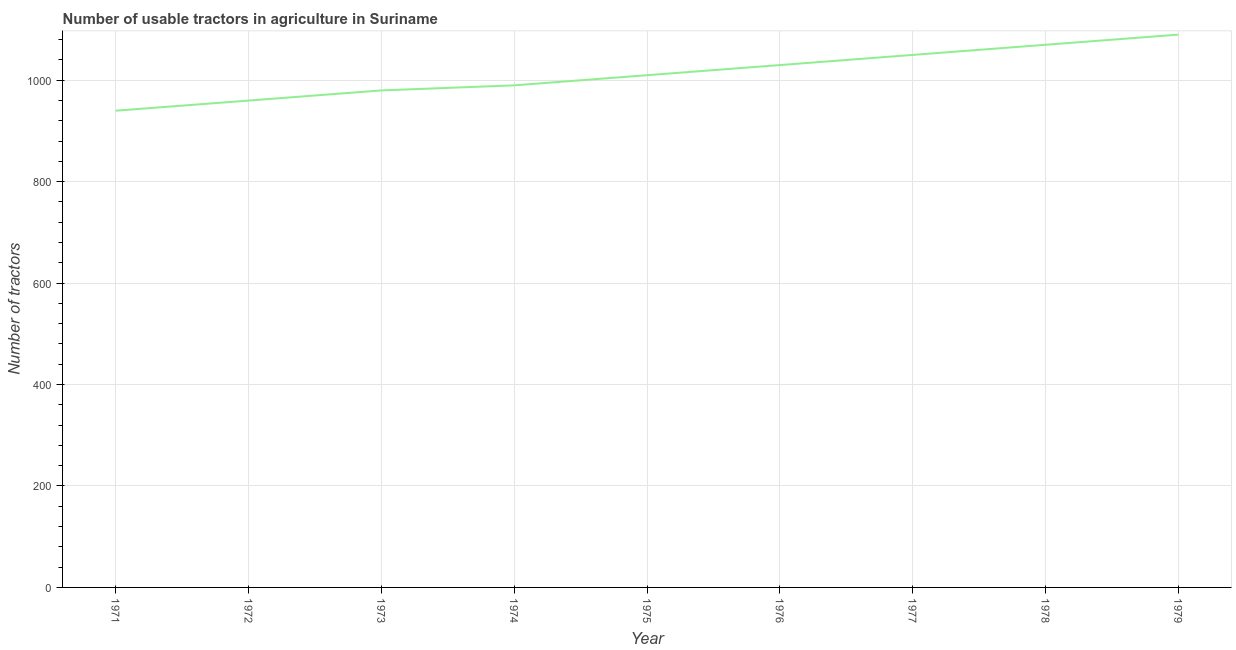What is the number of tractors in 1972?
Your response must be concise. 960. Across all years, what is the maximum number of tractors?
Give a very brief answer. 1090. Across all years, what is the minimum number of tractors?
Offer a terse response. 940. In which year was the number of tractors maximum?
Your answer should be very brief. 1979. What is the sum of the number of tractors?
Make the answer very short. 9120. What is the difference between the number of tractors in 1973 and 1977?
Give a very brief answer. -70. What is the average number of tractors per year?
Provide a short and direct response. 1013.33. What is the median number of tractors?
Provide a succinct answer. 1010. In how many years, is the number of tractors greater than 800 ?
Ensure brevity in your answer.  9. What is the ratio of the number of tractors in 1971 to that in 1973?
Give a very brief answer. 0.96. What is the difference between the highest and the second highest number of tractors?
Your answer should be compact. 20. What is the difference between the highest and the lowest number of tractors?
Your response must be concise. 150. What is the difference between two consecutive major ticks on the Y-axis?
Offer a terse response. 200. Are the values on the major ticks of Y-axis written in scientific E-notation?
Give a very brief answer. No. What is the title of the graph?
Your answer should be very brief. Number of usable tractors in agriculture in Suriname. What is the label or title of the Y-axis?
Offer a very short reply. Number of tractors. What is the Number of tractors of 1971?
Make the answer very short. 940. What is the Number of tractors of 1972?
Give a very brief answer. 960. What is the Number of tractors of 1973?
Offer a terse response. 980. What is the Number of tractors in 1974?
Make the answer very short. 990. What is the Number of tractors in 1975?
Make the answer very short. 1010. What is the Number of tractors in 1976?
Provide a succinct answer. 1030. What is the Number of tractors of 1977?
Ensure brevity in your answer.  1050. What is the Number of tractors of 1978?
Your answer should be very brief. 1070. What is the Number of tractors of 1979?
Ensure brevity in your answer.  1090. What is the difference between the Number of tractors in 1971 and 1972?
Your answer should be compact. -20. What is the difference between the Number of tractors in 1971 and 1975?
Give a very brief answer. -70. What is the difference between the Number of tractors in 1971 and 1976?
Keep it short and to the point. -90. What is the difference between the Number of tractors in 1971 and 1977?
Offer a terse response. -110. What is the difference between the Number of tractors in 1971 and 1978?
Your response must be concise. -130. What is the difference between the Number of tractors in 1971 and 1979?
Your answer should be very brief. -150. What is the difference between the Number of tractors in 1972 and 1974?
Your answer should be compact. -30. What is the difference between the Number of tractors in 1972 and 1976?
Make the answer very short. -70. What is the difference between the Number of tractors in 1972 and 1977?
Make the answer very short. -90. What is the difference between the Number of tractors in 1972 and 1978?
Your answer should be compact. -110. What is the difference between the Number of tractors in 1972 and 1979?
Your response must be concise. -130. What is the difference between the Number of tractors in 1973 and 1975?
Keep it short and to the point. -30. What is the difference between the Number of tractors in 1973 and 1977?
Your response must be concise. -70. What is the difference between the Number of tractors in 1973 and 1978?
Provide a short and direct response. -90. What is the difference between the Number of tractors in 1973 and 1979?
Offer a terse response. -110. What is the difference between the Number of tractors in 1974 and 1975?
Your answer should be very brief. -20. What is the difference between the Number of tractors in 1974 and 1977?
Your response must be concise. -60. What is the difference between the Number of tractors in 1974 and 1978?
Your answer should be very brief. -80. What is the difference between the Number of tractors in 1974 and 1979?
Your answer should be compact. -100. What is the difference between the Number of tractors in 1975 and 1976?
Ensure brevity in your answer.  -20. What is the difference between the Number of tractors in 1975 and 1977?
Your response must be concise. -40. What is the difference between the Number of tractors in 1975 and 1978?
Provide a succinct answer. -60. What is the difference between the Number of tractors in 1975 and 1979?
Your response must be concise. -80. What is the difference between the Number of tractors in 1976 and 1977?
Provide a succinct answer. -20. What is the difference between the Number of tractors in 1976 and 1978?
Ensure brevity in your answer.  -40. What is the difference between the Number of tractors in 1976 and 1979?
Provide a short and direct response. -60. What is the difference between the Number of tractors in 1977 and 1978?
Your response must be concise. -20. What is the difference between the Number of tractors in 1977 and 1979?
Ensure brevity in your answer.  -40. What is the difference between the Number of tractors in 1978 and 1979?
Keep it short and to the point. -20. What is the ratio of the Number of tractors in 1971 to that in 1973?
Make the answer very short. 0.96. What is the ratio of the Number of tractors in 1971 to that in 1974?
Your answer should be compact. 0.95. What is the ratio of the Number of tractors in 1971 to that in 1976?
Provide a short and direct response. 0.91. What is the ratio of the Number of tractors in 1971 to that in 1977?
Give a very brief answer. 0.9. What is the ratio of the Number of tractors in 1971 to that in 1978?
Ensure brevity in your answer.  0.88. What is the ratio of the Number of tractors in 1971 to that in 1979?
Your response must be concise. 0.86. What is the ratio of the Number of tractors in 1972 to that in 1973?
Offer a terse response. 0.98. What is the ratio of the Number of tractors in 1972 to that in 1975?
Ensure brevity in your answer.  0.95. What is the ratio of the Number of tractors in 1972 to that in 1976?
Keep it short and to the point. 0.93. What is the ratio of the Number of tractors in 1972 to that in 1977?
Ensure brevity in your answer.  0.91. What is the ratio of the Number of tractors in 1972 to that in 1978?
Provide a short and direct response. 0.9. What is the ratio of the Number of tractors in 1972 to that in 1979?
Your answer should be compact. 0.88. What is the ratio of the Number of tractors in 1973 to that in 1975?
Keep it short and to the point. 0.97. What is the ratio of the Number of tractors in 1973 to that in 1976?
Provide a short and direct response. 0.95. What is the ratio of the Number of tractors in 1973 to that in 1977?
Your answer should be very brief. 0.93. What is the ratio of the Number of tractors in 1973 to that in 1978?
Provide a succinct answer. 0.92. What is the ratio of the Number of tractors in 1973 to that in 1979?
Ensure brevity in your answer.  0.9. What is the ratio of the Number of tractors in 1974 to that in 1977?
Keep it short and to the point. 0.94. What is the ratio of the Number of tractors in 1974 to that in 1978?
Give a very brief answer. 0.93. What is the ratio of the Number of tractors in 1974 to that in 1979?
Provide a short and direct response. 0.91. What is the ratio of the Number of tractors in 1975 to that in 1976?
Make the answer very short. 0.98. What is the ratio of the Number of tractors in 1975 to that in 1978?
Ensure brevity in your answer.  0.94. What is the ratio of the Number of tractors in 1975 to that in 1979?
Keep it short and to the point. 0.93. What is the ratio of the Number of tractors in 1976 to that in 1977?
Offer a very short reply. 0.98. What is the ratio of the Number of tractors in 1976 to that in 1978?
Make the answer very short. 0.96. What is the ratio of the Number of tractors in 1976 to that in 1979?
Offer a terse response. 0.94. What is the ratio of the Number of tractors in 1977 to that in 1978?
Your response must be concise. 0.98. What is the ratio of the Number of tractors in 1977 to that in 1979?
Offer a terse response. 0.96. 